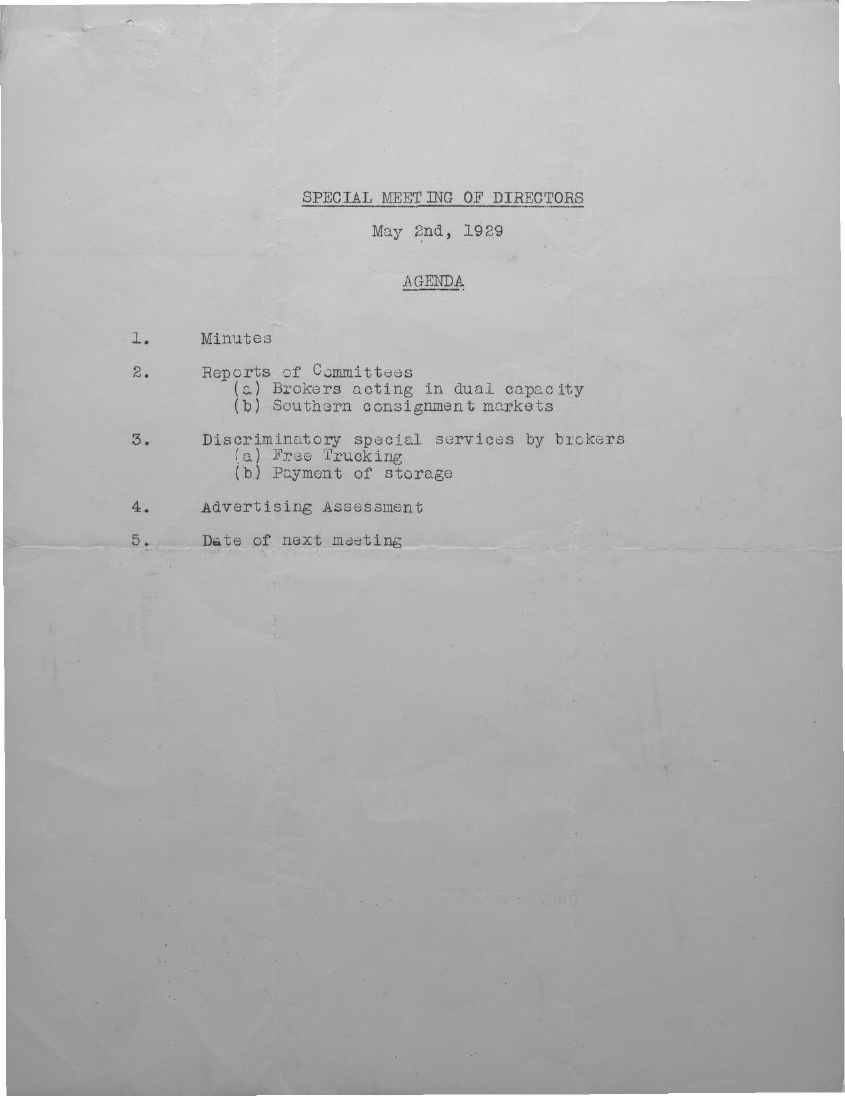Highlight a few significant elements in this photo. The special meeting of Directors was held on May 2nd, 1929. 